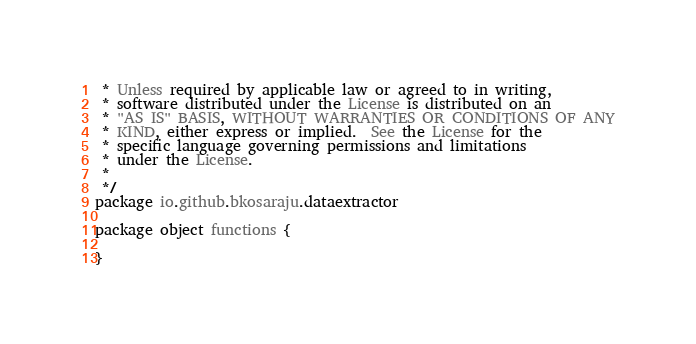Convert code to text. <code><loc_0><loc_0><loc_500><loc_500><_Scala_> * Unless required by applicable law or agreed to in writing,
 * software distributed under the License is distributed on an
 * "AS IS" BASIS, WITHOUT WARRANTIES OR CONDITIONS OF ANY
 * KIND, either express or implied.  See the License for the
 * specific language governing permissions and limitations
 * under the License.
 *
 */
package io.github.bkosaraju.dataextractor

package object functions {

}
</code> 